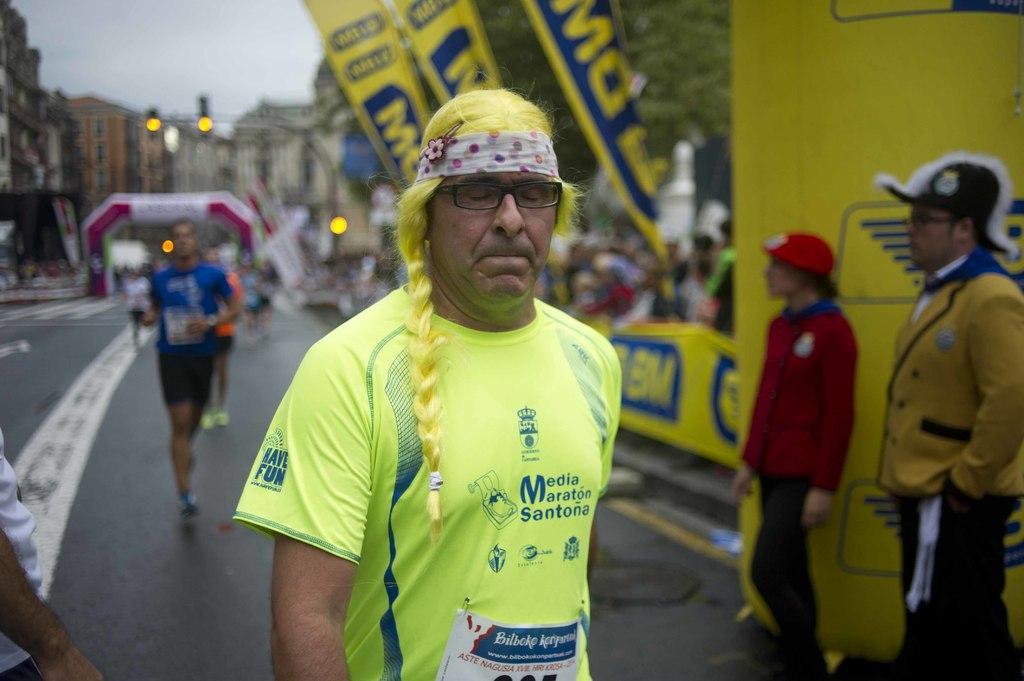Could you give a brief overview of what you see in this image? In this picture I can observe a person wearing yellow color T shirt and spectacles. He is walking on the road. On the right side I can observe two members standing on the road. In the background there are some people on the road. I can observe some buildings, trees and a sky. 